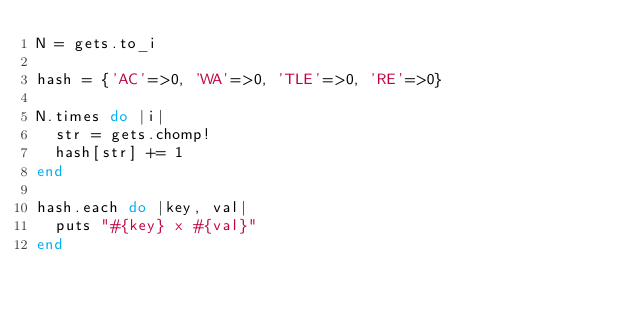Convert code to text. <code><loc_0><loc_0><loc_500><loc_500><_Ruby_>N = gets.to_i

hash = {'AC'=>0, 'WA'=>0, 'TLE'=>0, 'RE'=>0}

N.times do |i|
  str = gets.chomp!
  hash[str] += 1
end

hash.each do |key, val|
  puts "#{key} x #{val}"
end</code> 